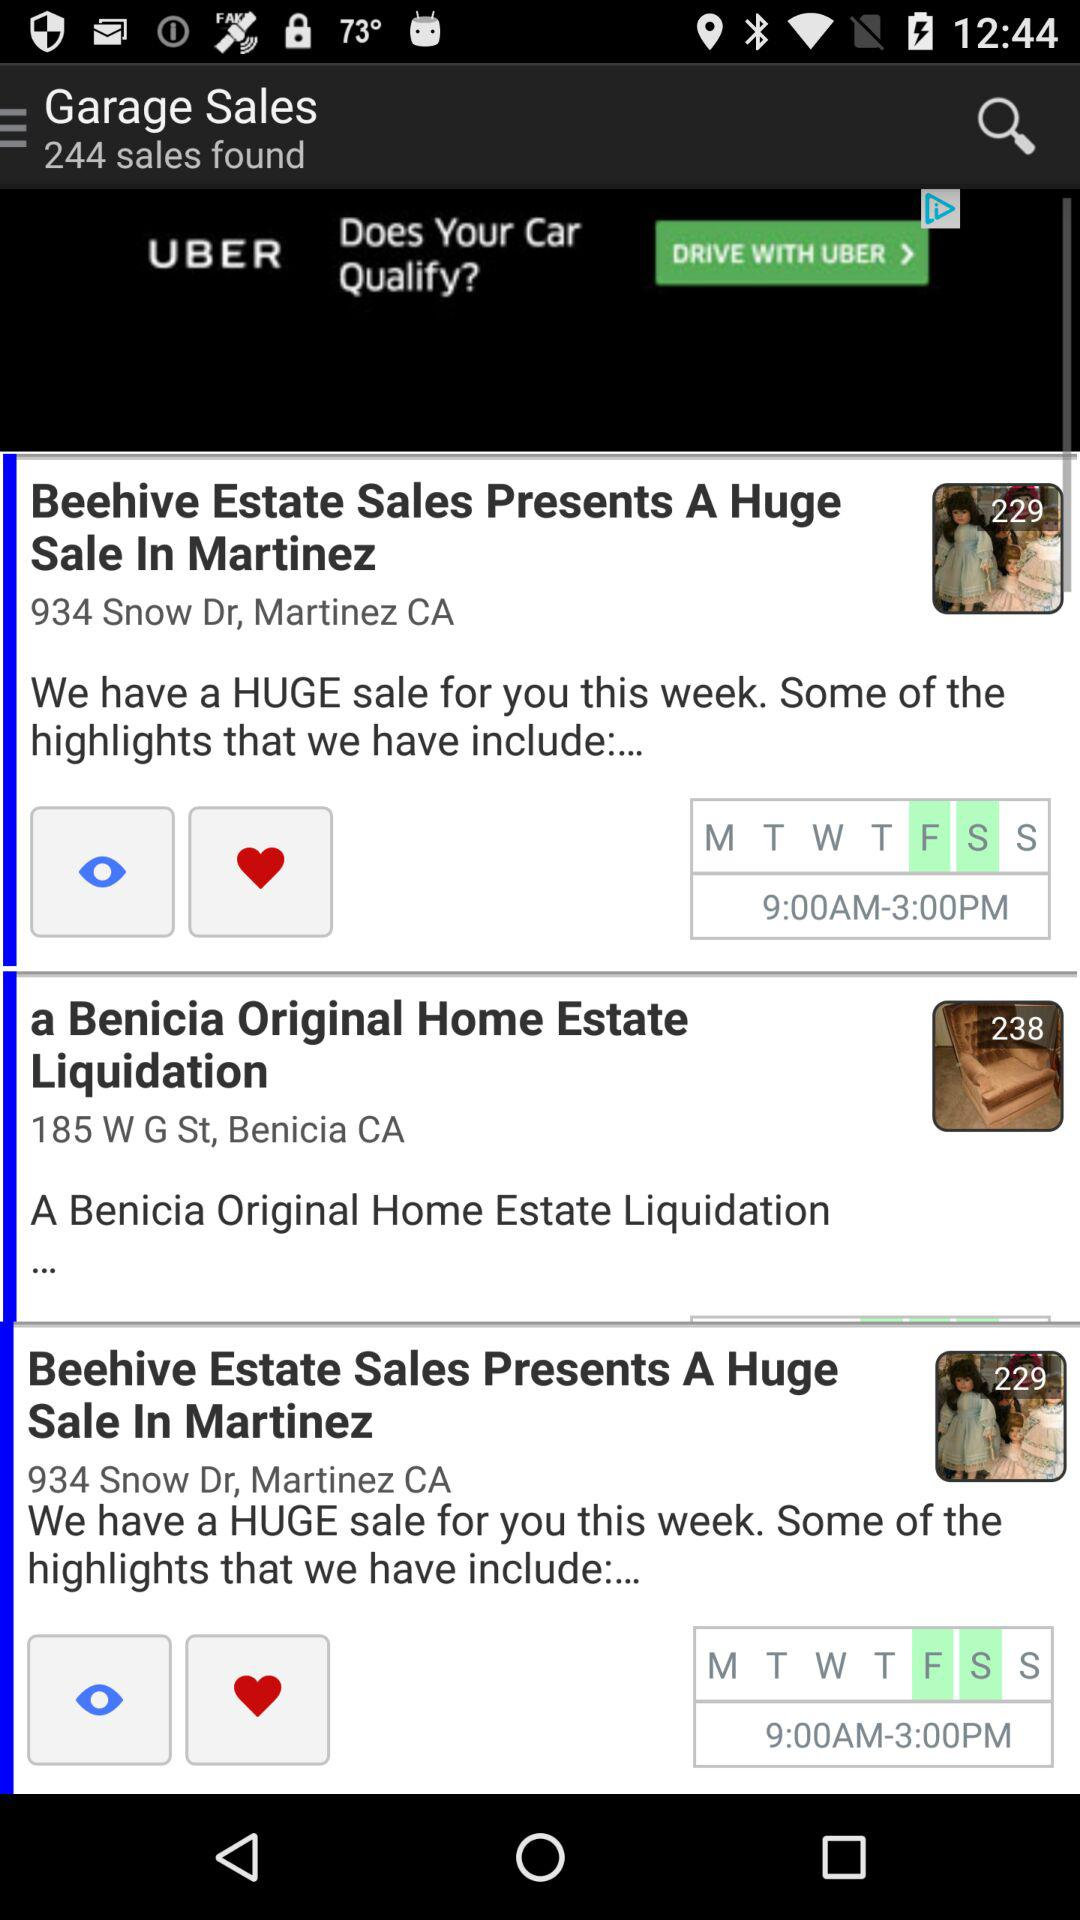Which day is selected for sale? The selected days are Friday and Saturday. 